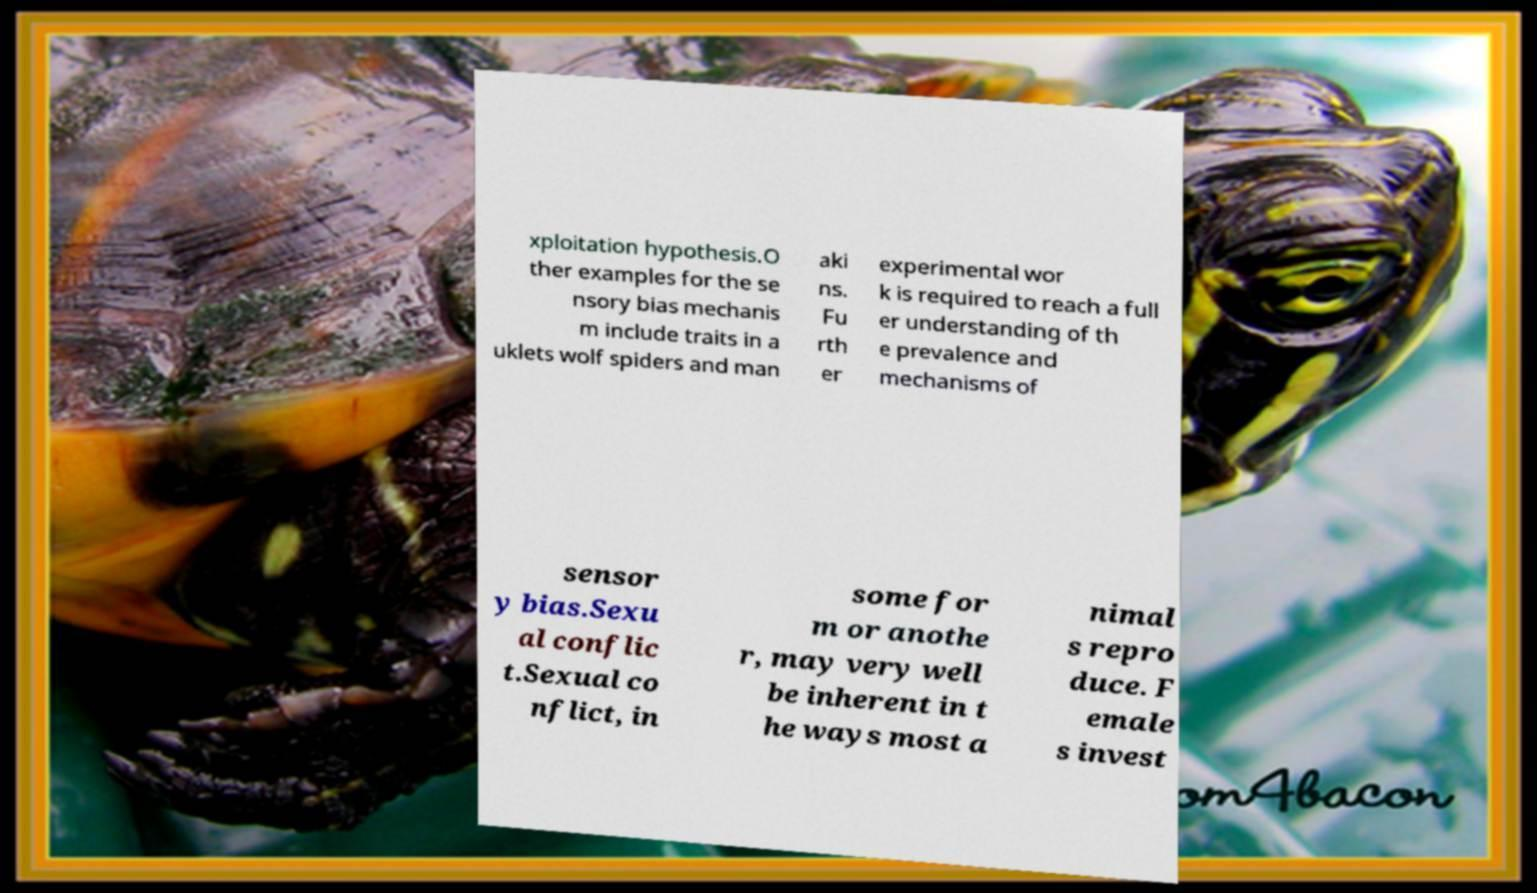Please read and relay the text visible in this image. What does it say? xploitation hypothesis.O ther examples for the se nsory bias mechanis m include traits in a uklets wolf spiders and man aki ns. Fu rth er experimental wor k is required to reach a full er understanding of th e prevalence and mechanisms of sensor y bias.Sexu al conflic t.Sexual co nflict, in some for m or anothe r, may very well be inherent in t he ways most a nimal s repro duce. F emale s invest 